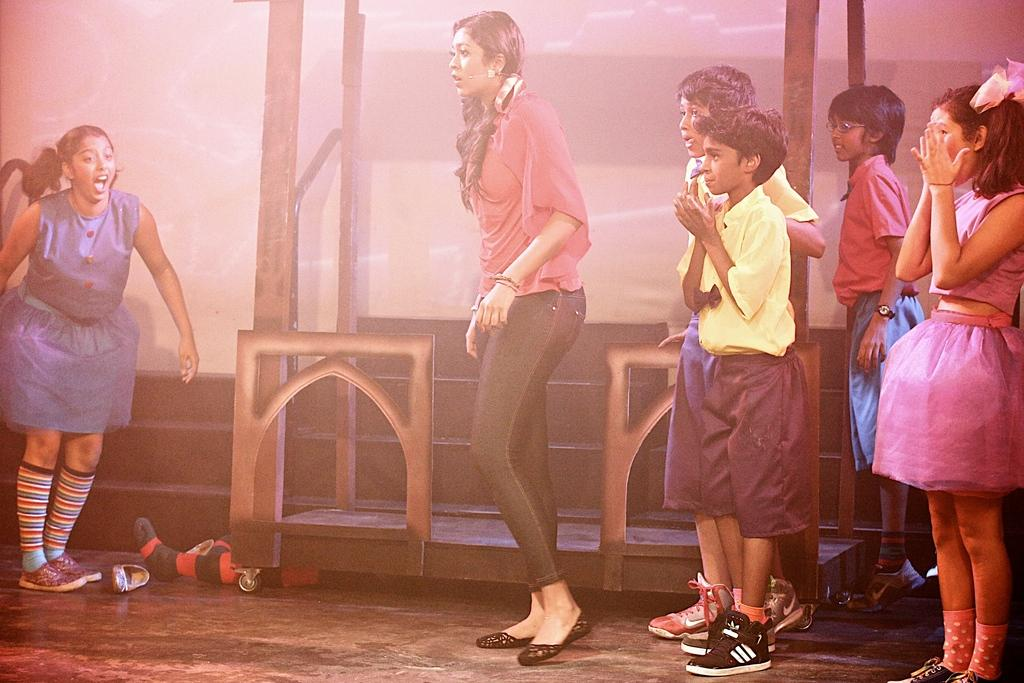What are the people in the image doing? The people in the image are standing on the ground. What type of clothing accessory can be seen in the image? There is footwear visible in the image. Can you describe any objects present in the image? Yes, there are objects present in the image. Can you tell me how many gooses are present in the image? There are no gooses present in the image. What type of emotion is the goat expressing in the image? There is no goat present in the image. 